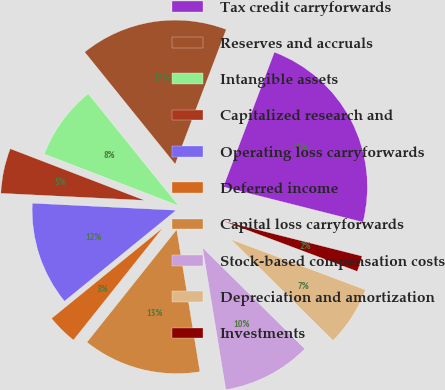Convert chart. <chart><loc_0><loc_0><loc_500><loc_500><pie_chart><fcel>Tax credit carryforwards<fcel>Reserves and accruals<fcel>Intangible assets<fcel>Capitalized research and<fcel>Operating loss carryforwards<fcel>Deferred income<fcel>Capital loss carryforwards<fcel>Stock-based compensation costs<fcel>Depreciation and amortization<fcel>Investments<nl><fcel>23.17%<fcel>16.58%<fcel>8.35%<fcel>5.06%<fcel>11.65%<fcel>3.42%<fcel>13.29%<fcel>10.0%<fcel>6.71%<fcel>1.77%<nl></chart> 